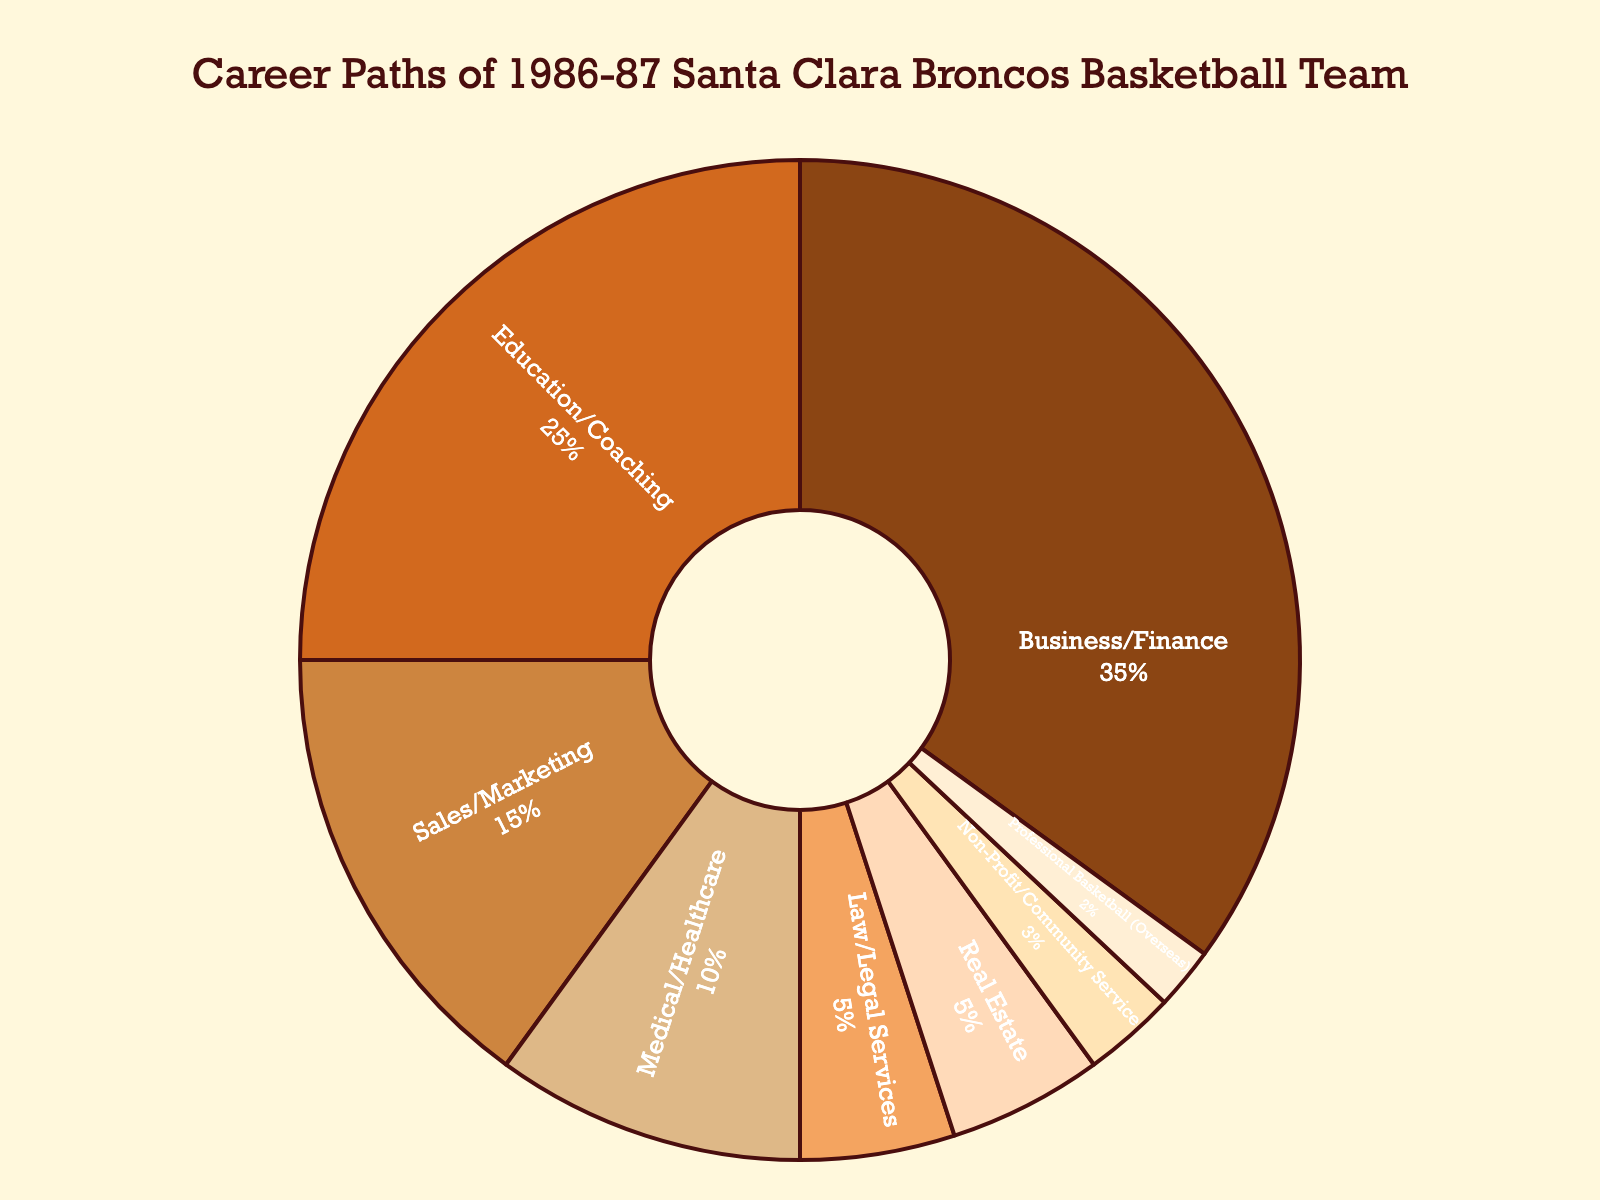What percentage of team members pursued careers in Real Estate and Law combined? To find the combined percentage of careers in Real Estate and Law, simply add the percentages for both categories: 5% (Real Estate) + 5% (Law/Legal Services) = 10%.
Answer: 10% Which career path was chosen by the smallest percentage of team members? To determine the least chosen career path, look for the smallest percentage value in the pie chart. Professional Basketball (Overseas) has the smallest slice, representing 2%.
Answer: Professional Basketball (Overseas) How much larger is the Business/Finance sector compared to the Non-Profit/Community Service sector? First, identify the percentages for both sectors: Business/Finance is 35% and Non-Profit/Community Service is 3%. Subtract the smaller percentage from the larger one: 35% - 3% = 32%.
Answer: 32% What percentage of team members went into either Education/Coaching or Sales/Marketing? Combine the percentages for Education/Coaching and Sales/Marketing: 25% (Education/Coaching) + 15% (Sales/Marketing) = 40%.
Answer: 40% Is the percentage of team members in Business/Finance greater than the sum of those in Medical/Healthcare and Real Estate? First, sum the percentages for Medical/Healthcare and Real Estate: 10% (Medical/Healthcare) + 5% (Real Estate) = 15%. Then, compare this sum to the percentage in Business/Finance, which is 35%. Since 35% > 15%, the answer is yes.
Answer: Yes What is the total percentage of team members who pursued a career in sports-related fields (i.e., Education/Coaching and Professional Basketball)? Add the percentages for Education/Coaching and Professional Basketball: 25% (Education/Coaching) + 2% (Professional Basketball) = 27%.
Answer: 27% Which two sectors have the same percentage of team members? Identify the sectors with matching percentages by scanning the pie chart. Both Real Estate and Law/Legal Services are at 5%.
Answer: Real Estate and Law/Legal Services What is the difference in percentage points between the Education/Coaching and Medical/Healthcare sectors? Identify the percentages for each sector: Education/Coaching is 25% and Medical/Healthcare is 10%. Subtract the smaller percentage from the larger one: 25% - 10% = 15%.
Answer: 15% 